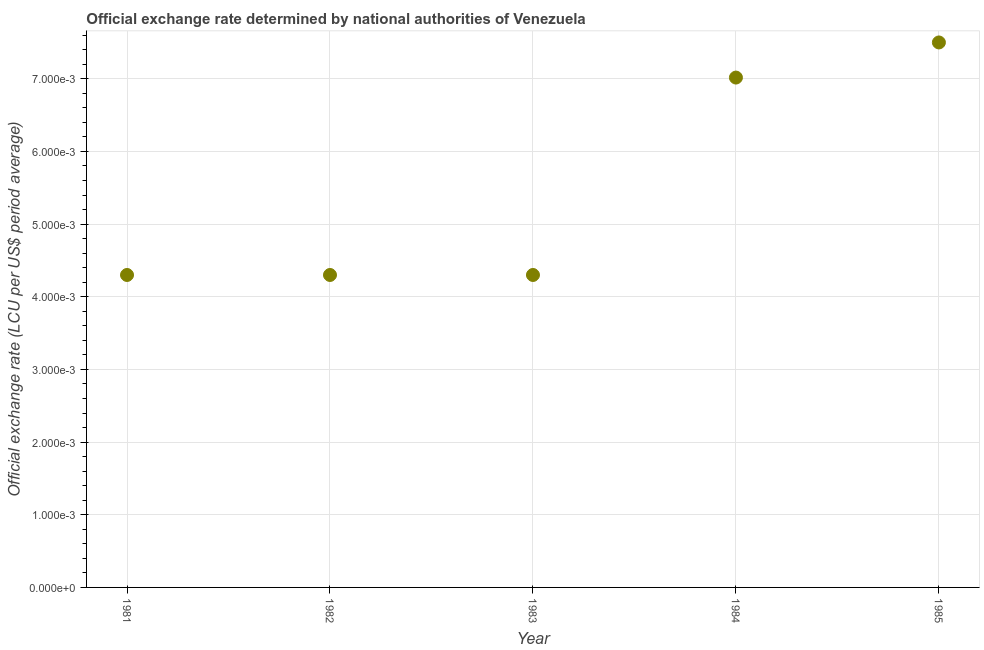What is the official exchange rate in 1984?
Offer a terse response. 0.01. Across all years, what is the maximum official exchange rate?
Give a very brief answer. 0.01. Across all years, what is the minimum official exchange rate?
Your answer should be very brief. 0. In which year was the official exchange rate maximum?
Your response must be concise. 1985. What is the sum of the official exchange rate?
Offer a terse response. 0.03. What is the difference between the official exchange rate in 1983 and 1984?
Offer a very short reply. -0. What is the average official exchange rate per year?
Offer a very short reply. 0.01. What is the median official exchange rate?
Provide a succinct answer. 0. Do a majority of the years between 1984 and 1983 (inclusive) have official exchange rate greater than 0.0012000000000000001 ?
Ensure brevity in your answer.  No. What is the ratio of the official exchange rate in 1982 to that in 1984?
Your answer should be compact. 0.61. Is the official exchange rate in 1982 less than that in 1984?
Keep it short and to the point. Yes. What is the difference between the highest and the second highest official exchange rate?
Provide a succinct answer. 0. Is the sum of the official exchange rate in 1981 and 1983 greater than the maximum official exchange rate across all years?
Keep it short and to the point. Yes. What is the difference between the highest and the lowest official exchange rate?
Keep it short and to the point. 0. In how many years, is the official exchange rate greater than the average official exchange rate taken over all years?
Give a very brief answer. 2. How many dotlines are there?
Your answer should be very brief. 1. How many years are there in the graph?
Your response must be concise. 5. Does the graph contain grids?
Your response must be concise. Yes. What is the title of the graph?
Offer a very short reply. Official exchange rate determined by national authorities of Venezuela. What is the label or title of the Y-axis?
Provide a succinct answer. Official exchange rate (LCU per US$ period average). What is the Official exchange rate (LCU per US$ period average) in 1981?
Keep it short and to the point. 0. What is the Official exchange rate (LCU per US$ period average) in 1982?
Your answer should be compact. 0. What is the Official exchange rate (LCU per US$ period average) in 1983?
Your response must be concise. 0. What is the Official exchange rate (LCU per US$ period average) in 1984?
Keep it short and to the point. 0.01. What is the Official exchange rate (LCU per US$ period average) in 1985?
Give a very brief answer. 0.01. What is the difference between the Official exchange rate (LCU per US$ period average) in 1981 and 1982?
Offer a very short reply. 0. What is the difference between the Official exchange rate (LCU per US$ period average) in 1981 and 1983?
Provide a succinct answer. 0. What is the difference between the Official exchange rate (LCU per US$ period average) in 1981 and 1984?
Your answer should be very brief. -0. What is the difference between the Official exchange rate (LCU per US$ period average) in 1981 and 1985?
Ensure brevity in your answer.  -0. What is the difference between the Official exchange rate (LCU per US$ period average) in 1982 and 1984?
Offer a very short reply. -0. What is the difference between the Official exchange rate (LCU per US$ period average) in 1982 and 1985?
Make the answer very short. -0. What is the difference between the Official exchange rate (LCU per US$ period average) in 1983 and 1984?
Make the answer very short. -0. What is the difference between the Official exchange rate (LCU per US$ period average) in 1983 and 1985?
Offer a very short reply. -0. What is the difference between the Official exchange rate (LCU per US$ period average) in 1984 and 1985?
Make the answer very short. -0. What is the ratio of the Official exchange rate (LCU per US$ period average) in 1981 to that in 1982?
Your answer should be very brief. 1. What is the ratio of the Official exchange rate (LCU per US$ period average) in 1981 to that in 1984?
Provide a succinct answer. 0.61. What is the ratio of the Official exchange rate (LCU per US$ period average) in 1981 to that in 1985?
Offer a terse response. 0.57. What is the ratio of the Official exchange rate (LCU per US$ period average) in 1982 to that in 1983?
Provide a succinct answer. 1. What is the ratio of the Official exchange rate (LCU per US$ period average) in 1982 to that in 1984?
Your response must be concise. 0.61. What is the ratio of the Official exchange rate (LCU per US$ period average) in 1982 to that in 1985?
Your response must be concise. 0.57. What is the ratio of the Official exchange rate (LCU per US$ period average) in 1983 to that in 1984?
Provide a short and direct response. 0.61. What is the ratio of the Official exchange rate (LCU per US$ period average) in 1983 to that in 1985?
Provide a succinct answer. 0.57. What is the ratio of the Official exchange rate (LCU per US$ period average) in 1984 to that in 1985?
Give a very brief answer. 0.94. 